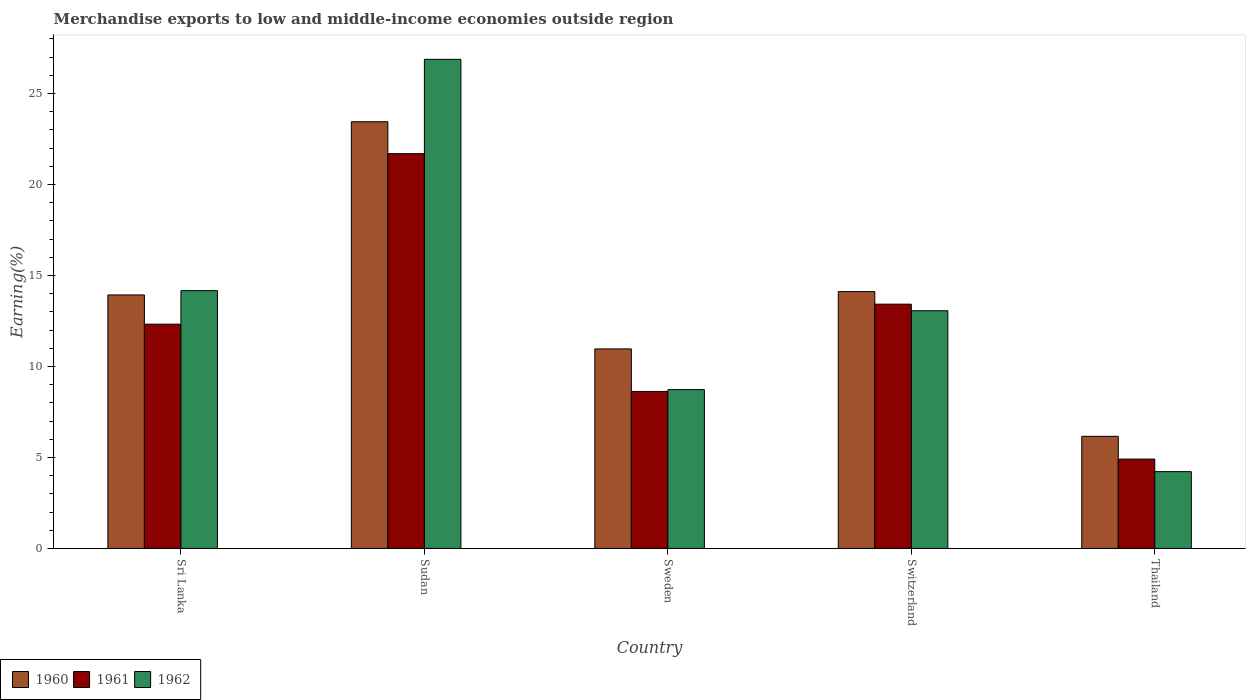How many different coloured bars are there?
Provide a short and direct response. 3. Are the number of bars on each tick of the X-axis equal?
Your response must be concise. Yes. How many bars are there on the 1st tick from the right?
Ensure brevity in your answer.  3. What is the label of the 5th group of bars from the left?
Give a very brief answer. Thailand. What is the percentage of amount earned from merchandise exports in 1962 in Sri Lanka?
Make the answer very short. 14.17. Across all countries, what is the maximum percentage of amount earned from merchandise exports in 1960?
Give a very brief answer. 23.45. Across all countries, what is the minimum percentage of amount earned from merchandise exports in 1961?
Your response must be concise. 4.91. In which country was the percentage of amount earned from merchandise exports in 1961 maximum?
Keep it short and to the point. Sudan. In which country was the percentage of amount earned from merchandise exports in 1962 minimum?
Offer a very short reply. Thailand. What is the total percentage of amount earned from merchandise exports in 1962 in the graph?
Your response must be concise. 67.05. What is the difference between the percentage of amount earned from merchandise exports in 1960 in Sudan and that in Switzerland?
Ensure brevity in your answer.  9.33. What is the difference between the percentage of amount earned from merchandise exports in 1962 in Switzerland and the percentage of amount earned from merchandise exports in 1960 in Sri Lanka?
Your response must be concise. -0.87. What is the average percentage of amount earned from merchandise exports in 1962 per country?
Your response must be concise. 13.41. What is the difference between the percentage of amount earned from merchandise exports of/in 1962 and percentage of amount earned from merchandise exports of/in 1960 in Sudan?
Keep it short and to the point. 3.43. What is the ratio of the percentage of amount earned from merchandise exports in 1962 in Sudan to that in Thailand?
Offer a terse response. 6.37. Is the difference between the percentage of amount earned from merchandise exports in 1962 in Sri Lanka and Switzerland greater than the difference between the percentage of amount earned from merchandise exports in 1960 in Sri Lanka and Switzerland?
Provide a short and direct response. Yes. What is the difference between the highest and the second highest percentage of amount earned from merchandise exports in 1960?
Offer a terse response. -0.18. What is the difference between the highest and the lowest percentage of amount earned from merchandise exports in 1960?
Offer a terse response. 17.29. Is the sum of the percentage of amount earned from merchandise exports in 1961 in Sudan and Thailand greater than the maximum percentage of amount earned from merchandise exports in 1962 across all countries?
Give a very brief answer. No. What does the 2nd bar from the left in Sudan represents?
Make the answer very short. 1961. What does the 2nd bar from the right in Thailand represents?
Give a very brief answer. 1961. How many bars are there?
Ensure brevity in your answer.  15. Are all the bars in the graph horizontal?
Offer a very short reply. No. How many countries are there in the graph?
Your answer should be very brief. 5. What is the difference between two consecutive major ticks on the Y-axis?
Your answer should be compact. 5. Does the graph contain any zero values?
Provide a succinct answer. No. What is the title of the graph?
Your answer should be very brief. Merchandise exports to low and middle-income economies outside region. Does "2004" appear as one of the legend labels in the graph?
Your response must be concise. No. What is the label or title of the Y-axis?
Your response must be concise. Earning(%). What is the Earning(%) in 1960 in Sri Lanka?
Make the answer very short. 13.93. What is the Earning(%) of 1961 in Sri Lanka?
Keep it short and to the point. 12.32. What is the Earning(%) of 1962 in Sri Lanka?
Your response must be concise. 14.17. What is the Earning(%) of 1960 in Sudan?
Offer a very short reply. 23.45. What is the Earning(%) in 1961 in Sudan?
Ensure brevity in your answer.  21.69. What is the Earning(%) of 1962 in Sudan?
Keep it short and to the point. 26.88. What is the Earning(%) of 1960 in Sweden?
Your response must be concise. 10.96. What is the Earning(%) in 1961 in Sweden?
Your answer should be very brief. 8.63. What is the Earning(%) in 1962 in Sweden?
Provide a succinct answer. 8.73. What is the Earning(%) in 1960 in Switzerland?
Your answer should be compact. 14.11. What is the Earning(%) in 1961 in Switzerland?
Ensure brevity in your answer.  13.42. What is the Earning(%) in 1962 in Switzerland?
Make the answer very short. 13.06. What is the Earning(%) of 1960 in Thailand?
Your answer should be compact. 6.16. What is the Earning(%) in 1961 in Thailand?
Provide a succinct answer. 4.91. What is the Earning(%) of 1962 in Thailand?
Make the answer very short. 4.22. Across all countries, what is the maximum Earning(%) in 1960?
Offer a terse response. 23.45. Across all countries, what is the maximum Earning(%) of 1961?
Provide a short and direct response. 21.69. Across all countries, what is the maximum Earning(%) of 1962?
Provide a short and direct response. 26.88. Across all countries, what is the minimum Earning(%) in 1960?
Ensure brevity in your answer.  6.16. Across all countries, what is the minimum Earning(%) in 1961?
Offer a terse response. 4.91. Across all countries, what is the minimum Earning(%) of 1962?
Your answer should be very brief. 4.22. What is the total Earning(%) in 1960 in the graph?
Keep it short and to the point. 68.61. What is the total Earning(%) of 1961 in the graph?
Give a very brief answer. 60.98. What is the total Earning(%) in 1962 in the graph?
Your response must be concise. 67.05. What is the difference between the Earning(%) of 1960 in Sri Lanka and that in Sudan?
Your answer should be very brief. -9.52. What is the difference between the Earning(%) in 1961 in Sri Lanka and that in Sudan?
Offer a very short reply. -9.37. What is the difference between the Earning(%) of 1962 in Sri Lanka and that in Sudan?
Your response must be concise. -12.71. What is the difference between the Earning(%) of 1960 in Sri Lanka and that in Sweden?
Give a very brief answer. 2.97. What is the difference between the Earning(%) of 1961 in Sri Lanka and that in Sweden?
Make the answer very short. 3.7. What is the difference between the Earning(%) in 1962 in Sri Lanka and that in Sweden?
Offer a terse response. 5.44. What is the difference between the Earning(%) of 1960 in Sri Lanka and that in Switzerland?
Your answer should be compact. -0.18. What is the difference between the Earning(%) of 1961 in Sri Lanka and that in Switzerland?
Offer a terse response. -1.1. What is the difference between the Earning(%) in 1962 in Sri Lanka and that in Switzerland?
Your answer should be very brief. 1.11. What is the difference between the Earning(%) of 1960 in Sri Lanka and that in Thailand?
Your answer should be compact. 7.77. What is the difference between the Earning(%) in 1961 in Sri Lanka and that in Thailand?
Make the answer very short. 7.41. What is the difference between the Earning(%) in 1962 in Sri Lanka and that in Thailand?
Your answer should be very brief. 9.95. What is the difference between the Earning(%) in 1960 in Sudan and that in Sweden?
Keep it short and to the point. 12.48. What is the difference between the Earning(%) of 1961 in Sudan and that in Sweden?
Give a very brief answer. 13.07. What is the difference between the Earning(%) of 1962 in Sudan and that in Sweden?
Offer a very short reply. 18.15. What is the difference between the Earning(%) of 1960 in Sudan and that in Switzerland?
Your answer should be compact. 9.33. What is the difference between the Earning(%) in 1961 in Sudan and that in Switzerland?
Ensure brevity in your answer.  8.27. What is the difference between the Earning(%) in 1962 in Sudan and that in Switzerland?
Give a very brief answer. 13.81. What is the difference between the Earning(%) of 1960 in Sudan and that in Thailand?
Your answer should be compact. 17.29. What is the difference between the Earning(%) of 1961 in Sudan and that in Thailand?
Provide a short and direct response. 16.78. What is the difference between the Earning(%) of 1962 in Sudan and that in Thailand?
Your answer should be very brief. 22.66. What is the difference between the Earning(%) of 1960 in Sweden and that in Switzerland?
Ensure brevity in your answer.  -3.15. What is the difference between the Earning(%) of 1961 in Sweden and that in Switzerland?
Keep it short and to the point. -4.8. What is the difference between the Earning(%) in 1962 in Sweden and that in Switzerland?
Provide a succinct answer. -4.33. What is the difference between the Earning(%) of 1960 in Sweden and that in Thailand?
Give a very brief answer. 4.8. What is the difference between the Earning(%) of 1961 in Sweden and that in Thailand?
Your response must be concise. 3.72. What is the difference between the Earning(%) in 1962 in Sweden and that in Thailand?
Provide a short and direct response. 4.51. What is the difference between the Earning(%) of 1960 in Switzerland and that in Thailand?
Make the answer very short. 7.95. What is the difference between the Earning(%) of 1961 in Switzerland and that in Thailand?
Your answer should be compact. 8.51. What is the difference between the Earning(%) of 1962 in Switzerland and that in Thailand?
Your answer should be compact. 8.84. What is the difference between the Earning(%) in 1960 in Sri Lanka and the Earning(%) in 1961 in Sudan?
Ensure brevity in your answer.  -7.76. What is the difference between the Earning(%) of 1960 in Sri Lanka and the Earning(%) of 1962 in Sudan?
Keep it short and to the point. -12.95. What is the difference between the Earning(%) in 1961 in Sri Lanka and the Earning(%) in 1962 in Sudan?
Your answer should be very brief. -14.55. What is the difference between the Earning(%) of 1960 in Sri Lanka and the Earning(%) of 1961 in Sweden?
Offer a terse response. 5.3. What is the difference between the Earning(%) of 1960 in Sri Lanka and the Earning(%) of 1962 in Sweden?
Make the answer very short. 5.2. What is the difference between the Earning(%) in 1961 in Sri Lanka and the Earning(%) in 1962 in Sweden?
Offer a very short reply. 3.6. What is the difference between the Earning(%) in 1960 in Sri Lanka and the Earning(%) in 1961 in Switzerland?
Your response must be concise. 0.51. What is the difference between the Earning(%) in 1960 in Sri Lanka and the Earning(%) in 1962 in Switzerland?
Ensure brevity in your answer.  0.87. What is the difference between the Earning(%) in 1961 in Sri Lanka and the Earning(%) in 1962 in Switzerland?
Give a very brief answer. -0.74. What is the difference between the Earning(%) of 1960 in Sri Lanka and the Earning(%) of 1961 in Thailand?
Provide a short and direct response. 9.02. What is the difference between the Earning(%) in 1960 in Sri Lanka and the Earning(%) in 1962 in Thailand?
Provide a short and direct response. 9.71. What is the difference between the Earning(%) of 1961 in Sri Lanka and the Earning(%) of 1962 in Thailand?
Offer a very short reply. 8.1. What is the difference between the Earning(%) in 1960 in Sudan and the Earning(%) in 1961 in Sweden?
Offer a very short reply. 14.82. What is the difference between the Earning(%) in 1960 in Sudan and the Earning(%) in 1962 in Sweden?
Provide a short and direct response. 14.72. What is the difference between the Earning(%) of 1961 in Sudan and the Earning(%) of 1962 in Sweden?
Keep it short and to the point. 12.97. What is the difference between the Earning(%) in 1960 in Sudan and the Earning(%) in 1961 in Switzerland?
Offer a very short reply. 10.02. What is the difference between the Earning(%) of 1960 in Sudan and the Earning(%) of 1962 in Switzerland?
Give a very brief answer. 10.38. What is the difference between the Earning(%) of 1961 in Sudan and the Earning(%) of 1962 in Switzerland?
Provide a succinct answer. 8.63. What is the difference between the Earning(%) in 1960 in Sudan and the Earning(%) in 1961 in Thailand?
Give a very brief answer. 18.54. What is the difference between the Earning(%) of 1960 in Sudan and the Earning(%) of 1962 in Thailand?
Give a very brief answer. 19.23. What is the difference between the Earning(%) of 1961 in Sudan and the Earning(%) of 1962 in Thailand?
Your response must be concise. 17.47. What is the difference between the Earning(%) of 1960 in Sweden and the Earning(%) of 1961 in Switzerland?
Provide a succinct answer. -2.46. What is the difference between the Earning(%) of 1960 in Sweden and the Earning(%) of 1962 in Switzerland?
Ensure brevity in your answer.  -2.1. What is the difference between the Earning(%) in 1961 in Sweden and the Earning(%) in 1962 in Switzerland?
Offer a terse response. -4.43. What is the difference between the Earning(%) in 1960 in Sweden and the Earning(%) in 1961 in Thailand?
Ensure brevity in your answer.  6.05. What is the difference between the Earning(%) in 1960 in Sweden and the Earning(%) in 1962 in Thailand?
Provide a succinct answer. 6.74. What is the difference between the Earning(%) in 1961 in Sweden and the Earning(%) in 1962 in Thailand?
Keep it short and to the point. 4.41. What is the difference between the Earning(%) of 1960 in Switzerland and the Earning(%) of 1961 in Thailand?
Offer a very short reply. 9.2. What is the difference between the Earning(%) in 1960 in Switzerland and the Earning(%) in 1962 in Thailand?
Ensure brevity in your answer.  9.89. What is the difference between the Earning(%) of 1961 in Switzerland and the Earning(%) of 1962 in Thailand?
Ensure brevity in your answer.  9.2. What is the average Earning(%) of 1960 per country?
Provide a short and direct response. 13.72. What is the average Earning(%) of 1961 per country?
Your answer should be very brief. 12.2. What is the average Earning(%) of 1962 per country?
Make the answer very short. 13.41. What is the difference between the Earning(%) in 1960 and Earning(%) in 1961 in Sri Lanka?
Make the answer very short. 1.61. What is the difference between the Earning(%) of 1960 and Earning(%) of 1962 in Sri Lanka?
Offer a very short reply. -0.24. What is the difference between the Earning(%) in 1961 and Earning(%) in 1962 in Sri Lanka?
Provide a short and direct response. -1.84. What is the difference between the Earning(%) in 1960 and Earning(%) in 1961 in Sudan?
Your answer should be very brief. 1.75. What is the difference between the Earning(%) of 1960 and Earning(%) of 1962 in Sudan?
Give a very brief answer. -3.43. What is the difference between the Earning(%) of 1961 and Earning(%) of 1962 in Sudan?
Offer a very short reply. -5.18. What is the difference between the Earning(%) of 1960 and Earning(%) of 1961 in Sweden?
Offer a very short reply. 2.34. What is the difference between the Earning(%) in 1960 and Earning(%) in 1962 in Sweden?
Your answer should be very brief. 2.24. What is the difference between the Earning(%) of 1961 and Earning(%) of 1962 in Sweden?
Offer a very short reply. -0.1. What is the difference between the Earning(%) of 1960 and Earning(%) of 1961 in Switzerland?
Provide a short and direct response. 0.69. What is the difference between the Earning(%) in 1960 and Earning(%) in 1962 in Switzerland?
Offer a very short reply. 1.05. What is the difference between the Earning(%) in 1961 and Earning(%) in 1962 in Switzerland?
Offer a terse response. 0.36. What is the difference between the Earning(%) of 1960 and Earning(%) of 1961 in Thailand?
Make the answer very short. 1.25. What is the difference between the Earning(%) in 1960 and Earning(%) in 1962 in Thailand?
Ensure brevity in your answer.  1.94. What is the difference between the Earning(%) in 1961 and Earning(%) in 1962 in Thailand?
Make the answer very short. 0.69. What is the ratio of the Earning(%) of 1960 in Sri Lanka to that in Sudan?
Give a very brief answer. 0.59. What is the ratio of the Earning(%) in 1961 in Sri Lanka to that in Sudan?
Offer a terse response. 0.57. What is the ratio of the Earning(%) in 1962 in Sri Lanka to that in Sudan?
Ensure brevity in your answer.  0.53. What is the ratio of the Earning(%) in 1960 in Sri Lanka to that in Sweden?
Offer a terse response. 1.27. What is the ratio of the Earning(%) in 1961 in Sri Lanka to that in Sweden?
Provide a short and direct response. 1.43. What is the ratio of the Earning(%) of 1962 in Sri Lanka to that in Sweden?
Keep it short and to the point. 1.62. What is the ratio of the Earning(%) of 1961 in Sri Lanka to that in Switzerland?
Offer a terse response. 0.92. What is the ratio of the Earning(%) of 1962 in Sri Lanka to that in Switzerland?
Offer a very short reply. 1.08. What is the ratio of the Earning(%) in 1960 in Sri Lanka to that in Thailand?
Offer a terse response. 2.26. What is the ratio of the Earning(%) in 1961 in Sri Lanka to that in Thailand?
Ensure brevity in your answer.  2.51. What is the ratio of the Earning(%) of 1962 in Sri Lanka to that in Thailand?
Keep it short and to the point. 3.36. What is the ratio of the Earning(%) of 1960 in Sudan to that in Sweden?
Your answer should be very brief. 2.14. What is the ratio of the Earning(%) of 1961 in Sudan to that in Sweden?
Keep it short and to the point. 2.51. What is the ratio of the Earning(%) of 1962 in Sudan to that in Sweden?
Provide a short and direct response. 3.08. What is the ratio of the Earning(%) in 1960 in Sudan to that in Switzerland?
Offer a very short reply. 1.66. What is the ratio of the Earning(%) of 1961 in Sudan to that in Switzerland?
Offer a very short reply. 1.62. What is the ratio of the Earning(%) of 1962 in Sudan to that in Switzerland?
Provide a succinct answer. 2.06. What is the ratio of the Earning(%) of 1960 in Sudan to that in Thailand?
Provide a succinct answer. 3.81. What is the ratio of the Earning(%) in 1961 in Sudan to that in Thailand?
Your answer should be very brief. 4.42. What is the ratio of the Earning(%) of 1962 in Sudan to that in Thailand?
Offer a very short reply. 6.37. What is the ratio of the Earning(%) of 1960 in Sweden to that in Switzerland?
Provide a succinct answer. 0.78. What is the ratio of the Earning(%) of 1961 in Sweden to that in Switzerland?
Make the answer very short. 0.64. What is the ratio of the Earning(%) of 1962 in Sweden to that in Switzerland?
Your answer should be very brief. 0.67. What is the ratio of the Earning(%) of 1960 in Sweden to that in Thailand?
Ensure brevity in your answer.  1.78. What is the ratio of the Earning(%) in 1961 in Sweden to that in Thailand?
Offer a very short reply. 1.76. What is the ratio of the Earning(%) of 1962 in Sweden to that in Thailand?
Offer a terse response. 2.07. What is the ratio of the Earning(%) of 1960 in Switzerland to that in Thailand?
Provide a short and direct response. 2.29. What is the ratio of the Earning(%) of 1961 in Switzerland to that in Thailand?
Your response must be concise. 2.73. What is the ratio of the Earning(%) of 1962 in Switzerland to that in Thailand?
Make the answer very short. 3.1. What is the difference between the highest and the second highest Earning(%) of 1960?
Ensure brevity in your answer.  9.33. What is the difference between the highest and the second highest Earning(%) in 1961?
Provide a short and direct response. 8.27. What is the difference between the highest and the second highest Earning(%) of 1962?
Offer a very short reply. 12.71. What is the difference between the highest and the lowest Earning(%) in 1960?
Offer a very short reply. 17.29. What is the difference between the highest and the lowest Earning(%) in 1961?
Provide a short and direct response. 16.78. What is the difference between the highest and the lowest Earning(%) of 1962?
Provide a short and direct response. 22.66. 